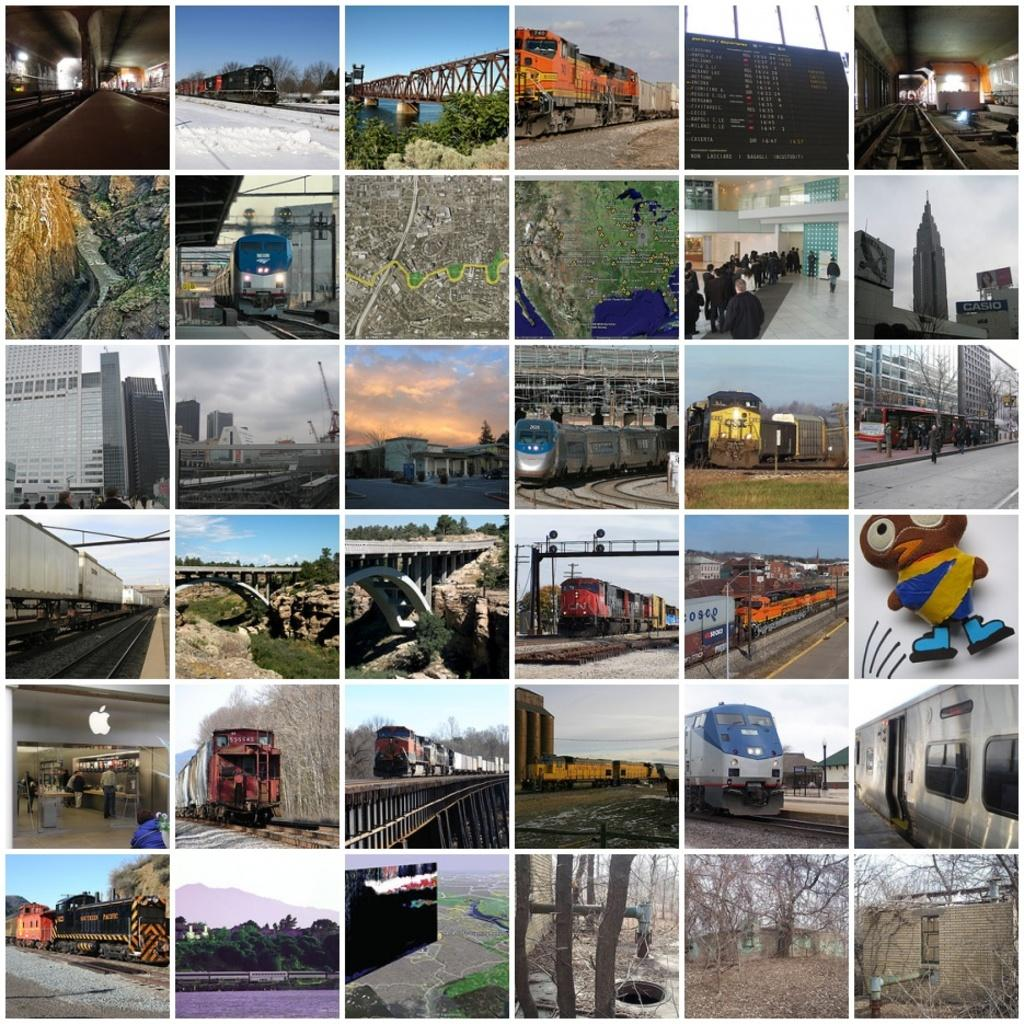What type of artwork is the image? The image is a collage. What transportation-related images can be found in the collage? There are pictures of a train, a bridge, and a subway in the collage. What other types of structures are depicted in the collage? There is a picture of a building and a house in the collage. How many quiet stems can be seen in the window of the house in the collage? There are no stems or windows visible in the house in the collage; it only shows a picture of a house. 